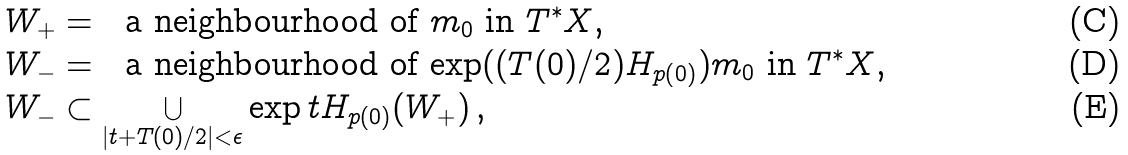Convert formula to latex. <formula><loc_0><loc_0><loc_500><loc_500>& W _ { + } = \ \text { a neighbourhood of $ m_{0} $ in $ T^{*} X $,} \\ & W _ { - } = \ \text { a neighbourhood of $ \exp ((T(0)/2) H_{ p (0) } ) m_{0} $ in $ T^{*} X $,} \\ & W _ { - } \subset \bigcup _ { | t + T ( 0 ) / 2 | < \epsilon } \exp t H _ { p ( 0 ) } ( W _ { + } ) \, ,</formula> 